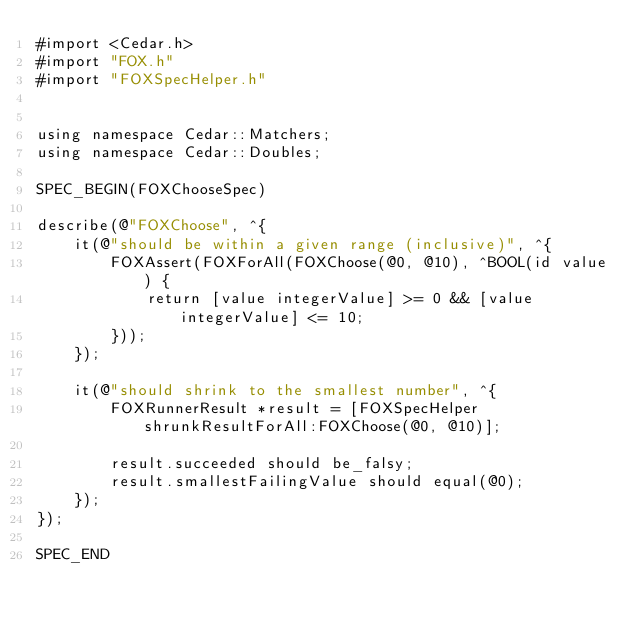<code> <loc_0><loc_0><loc_500><loc_500><_ObjectiveC_>#import <Cedar.h>
#import "FOX.h"
#import "FOXSpecHelper.h"


using namespace Cedar::Matchers;
using namespace Cedar::Doubles;

SPEC_BEGIN(FOXChooseSpec)

describe(@"FOXChoose", ^{
    it(@"should be within a given range (inclusive)", ^{
        FOXAssert(FOXForAll(FOXChoose(@0, @10), ^BOOL(id value) {
            return [value integerValue] >= 0 && [value integerValue] <= 10;
        }));
    });

    it(@"should shrink to the smallest number", ^{
        FOXRunnerResult *result = [FOXSpecHelper shrunkResultForAll:FOXChoose(@0, @10)];

        result.succeeded should be_falsy;
        result.smallestFailingValue should equal(@0);
    });
});

SPEC_END
</code> 